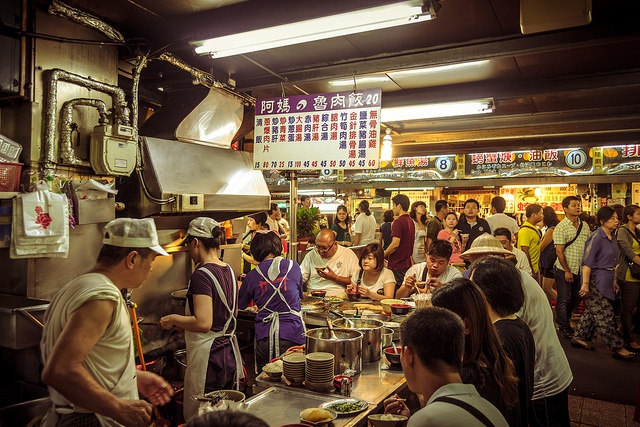Describe the objects in this image and their specific colors. I can see people in black, maroon, and olive tones, people in black, maroon, and tan tones, people in black, maroon, and tan tones, people in black, maroon, gray, and olive tones, and people in black, olive, gray, and maroon tones in this image. 